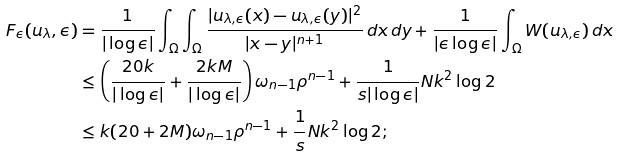Convert formula to latex. <formula><loc_0><loc_0><loc_500><loc_500>F _ { \epsilon } ( u _ { \lambda } , \epsilon ) & = \frac { 1 } { | \log \epsilon | } \int _ { \Omega } { \int _ { \Omega } { \frac { | u _ { \lambda , \epsilon } ( x ) - u _ { \lambda , \epsilon } ( y ) | ^ { 2 } } { | x - y | ^ { n + 1 } } \, d x \, d y } } + \frac { 1 } { | \epsilon \log \epsilon | } \int _ { \Omega } { W ( u _ { \lambda , \epsilon } ) \, d x } \\ & \leq \left ( \frac { 2 0 k } { | \log \epsilon | } + \frac { 2 k M } { | \log \epsilon | } \right ) \omega _ { n - 1 } \rho ^ { n - 1 } + \frac { 1 } { s | \log \epsilon | } N k ^ { 2 } \log 2 \\ & \leq k ( 2 0 + 2 M ) \omega _ { n - 1 } \rho ^ { n - 1 } + \frac { 1 } { s } N k ^ { 2 } \log 2 ;</formula> 